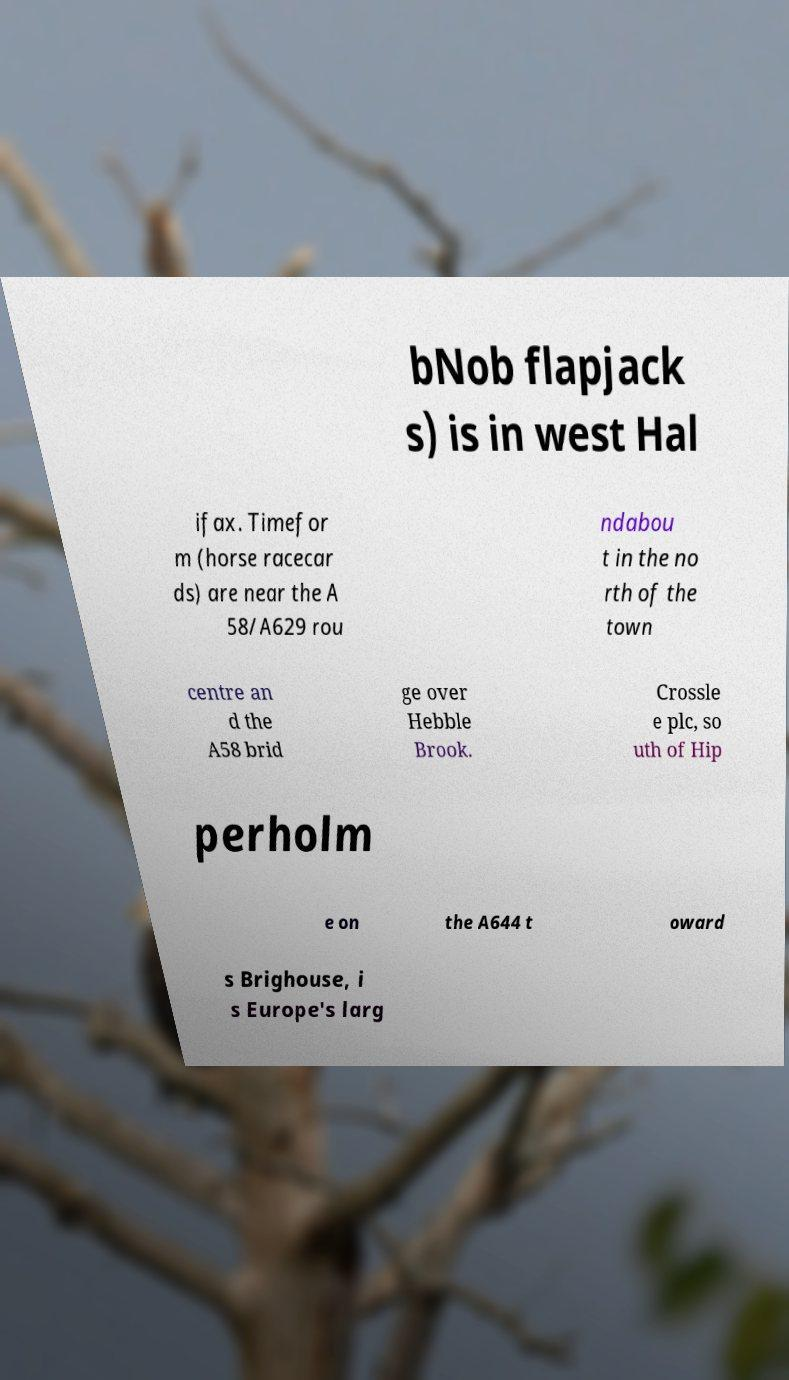Can you accurately transcribe the text from the provided image for me? bNob flapjack s) is in west Hal ifax. Timefor m (horse racecar ds) are near the A 58/A629 rou ndabou t in the no rth of the town centre an d the A58 brid ge over Hebble Brook. Crossle e plc, so uth of Hip perholm e on the A644 t oward s Brighouse, i s Europe's larg 